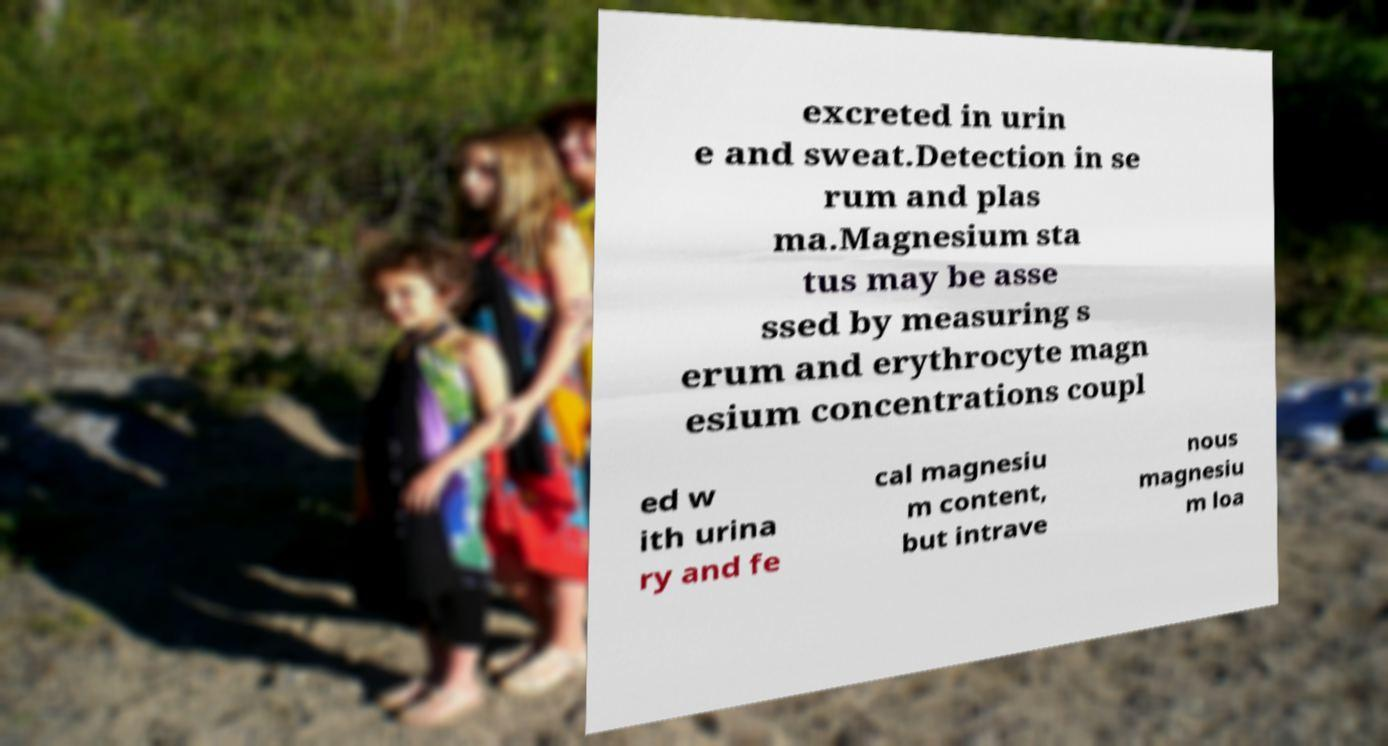Can you accurately transcribe the text from the provided image for me? excreted in urin e and sweat.Detection in se rum and plas ma.Magnesium sta tus may be asse ssed by measuring s erum and erythrocyte magn esium concentrations coupl ed w ith urina ry and fe cal magnesiu m content, but intrave nous magnesiu m loa 